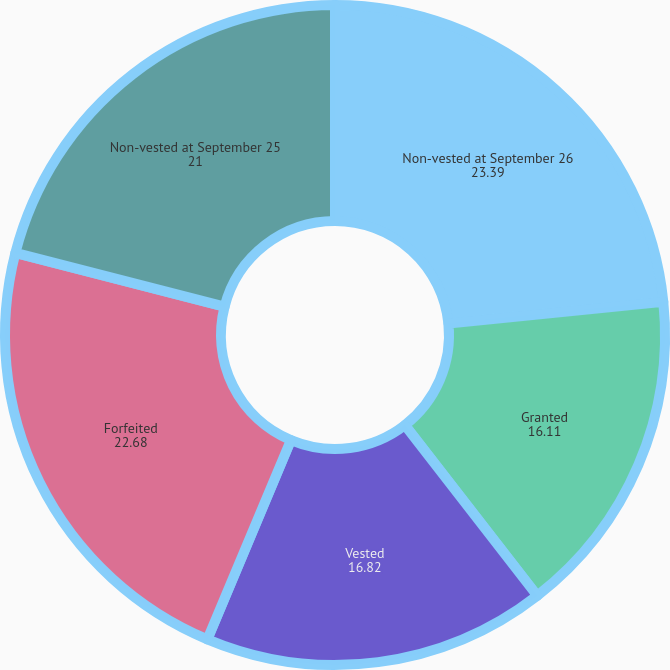Convert chart. <chart><loc_0><loc_0><loc_500><loc_500><pie_chart><fcel>Non-vested at September 26<fcel>Granted<fcel>Vested<fcel>Forfeited<fcel>Non-vested at September 25<nl><fcel>23.39%<fcel>16.11%<fcel>16.82%<fcel>22.68%<fcel>21.0%<nl></chart> 